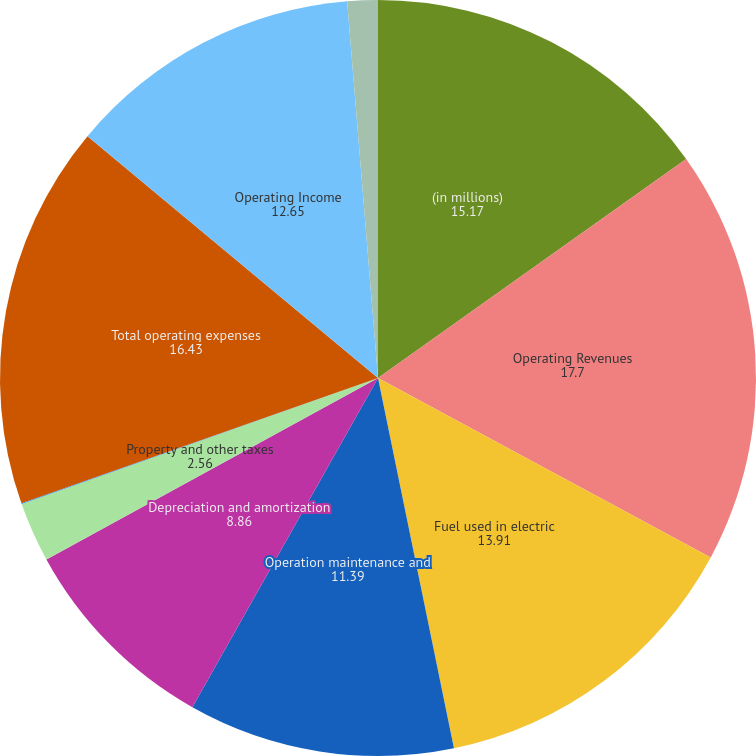<chart> <loc_0><loc_0><loc_500><loc_500><pie_chart><fcel>(in millions)<fcel>Operating Revenues<fcel>Fuel used in electric<fcel>Operation maintenance and<fcel>Depreciation and amortization<fcel>Property and other taxes<fcel>Impairment charges<fcel>Total operating expenses<fcel>Operating Income<fcel>Other Income and Expenses net<nl><fcel>15.17%<fcel>17.7%<fcel>13.91%<fcel>11.39%<fcel>8.86%<fcel>2.56%<fcel>0.03%<fcel>16.43%<fcel>12.65%<fcel>1.3%<nl></chart> 